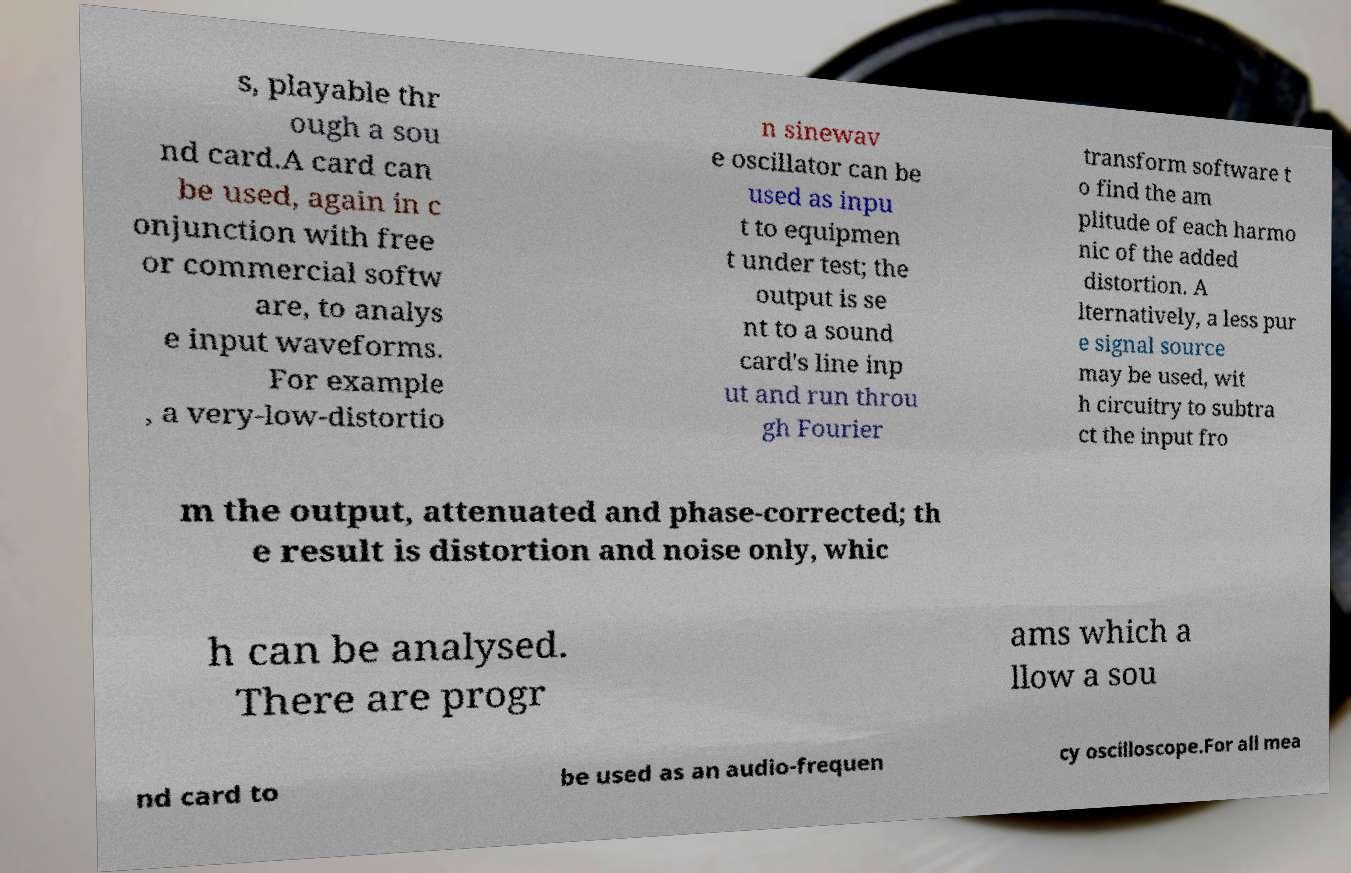What messages or text are displayed in this image? I need them in a readable, typed format. s, playable thr ough a sou nd card.A card can be used, again in c onjunction with free or commercial softw are, to analys e input waveforms. For example , a very-low-distortio n sinewav e oscillator can be used as inpu t to equipmen t under test; the output is se nt to a sound card's line inp ut and run throu gh Fourier transform software t o find the am plitude of each harmo nic of the added distortion. A lternatively, a less pur e signal source may be used, wit h circuitry to subtra ct the input fro m the output, attenuated and phase-corrected; th e result is distortion and noise only, whic h can be analysed. There are progr ams which a llow a sou nd card to be used as an audio-frequen cy oscilloscope.For all mea 